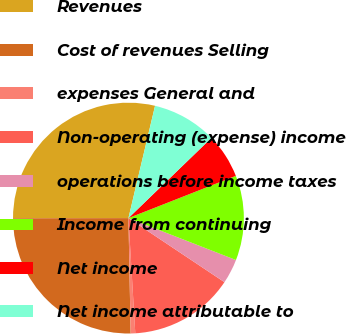Convert chart. <chart><loc_0><loc_0><loc_500><loc_500><pie_chart><fcel>Revenues<fcel>Cost of revenues Selling<fcel>expenses General and<fcel>Non-operating (expense) income<fcel>operations before income taxes<fcel>Income from continuing<fcel>Net income<fcel>Net income attributable to<nl><fcel>28.73%<fcel>25.28%<fcel>0.64%<fcel>14.69%<fcel>3.45%<fcel>11.88%<fcel>6.26%<fcel>9.07%<nl></chart> 